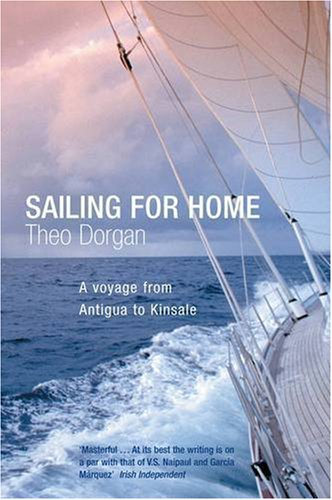Is this book related to Travel? Yes, this book is directly related to travel, describing a significant and personal journey across the seas documented by the author. 